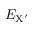<formula> <loc_0><loc_0><loc_500><loc_500>E _ { X ^ { \prime } }</formula> 